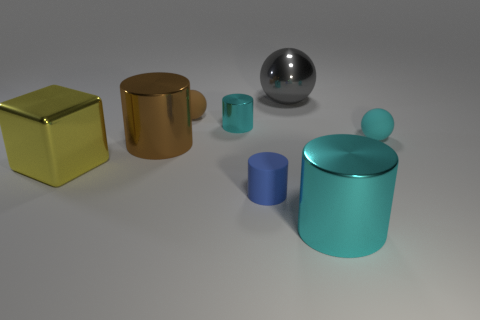Subtract 1 cylinders. How many cylinders are left? 3 Add 1 small red blocks. How many objects exist? 9 Subtract all spheres. How many objects are left? 5 Subtract 1 brown balls. How many objects are left? 7 Subtract all cyan metal objects. Subtract all tiny cyan cylinders. How many objects are left? 5 Add 2 small brown matte objects. How many small brown matte objects are left? 3 Add 3 tiny red rubber cubes. How many tiny red rubber cubes exist? 3 